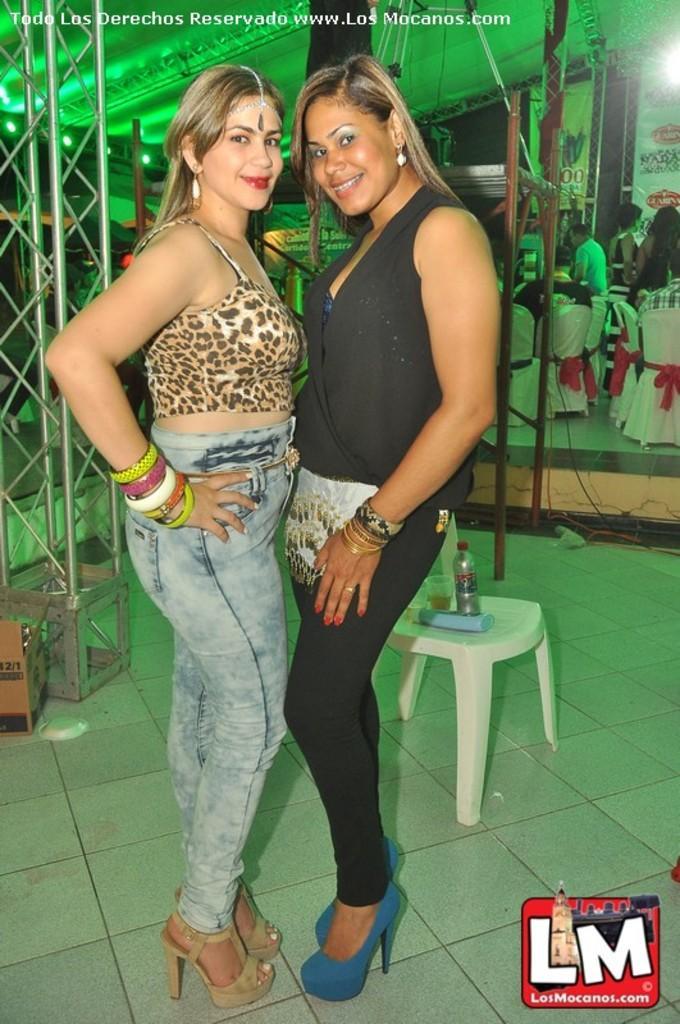How would you summarize this image in a sentence or two? This picture is clicked in the hotel. Two women in front of the picture are standing and they are posing for the photo. Behind them, we see a chair on which water bottle and glass are placed. On the left side, we see a pillar and a carton box. Behind them, we see people sitting on the chairs. Behind them, we see white banners with some text written on it. 